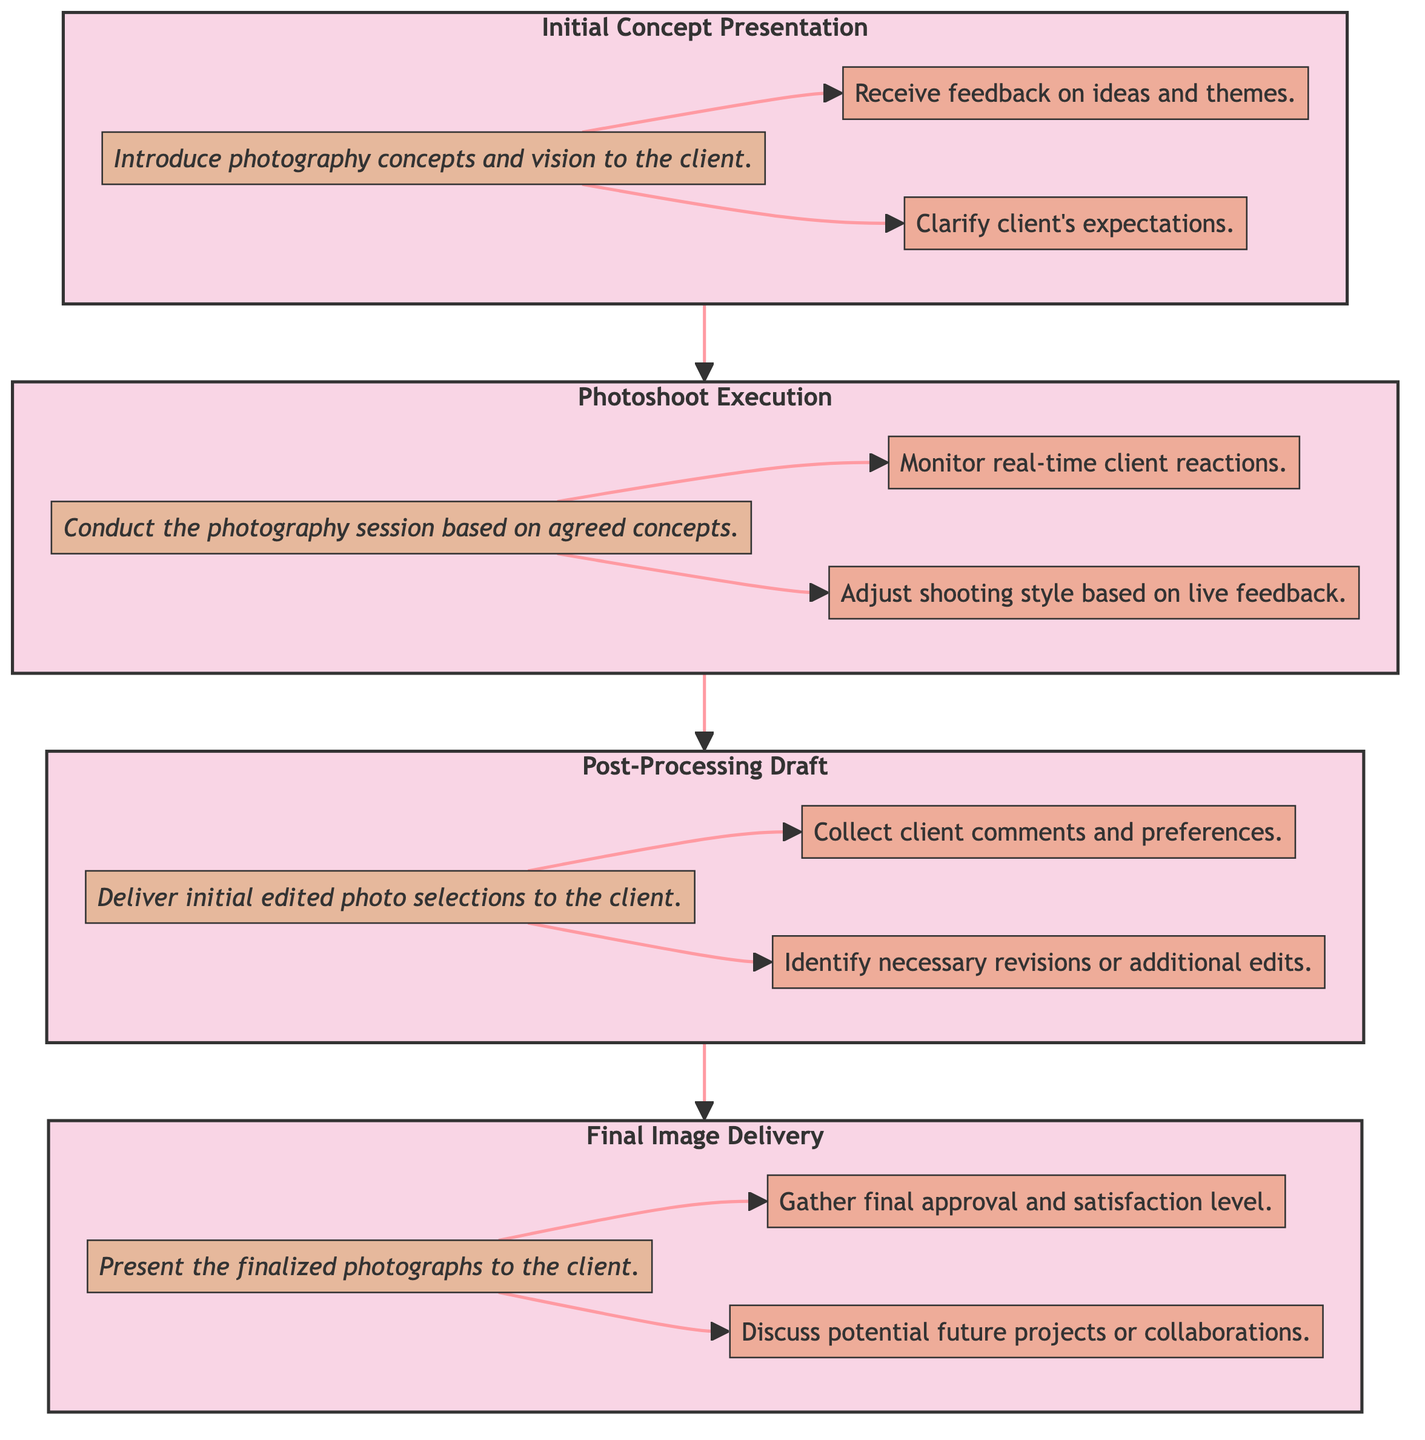What is the first stage in the client feedback loop? The diagram clearly indicates the order of stages, starting with "Initial Concept Presentation," which is the first stage in the client feedback loop.
Answer: Initial Concept Presentation How many response actions are linked to the "Final Image Delivery" stage? By examining the "Final Image Delivery" stage, we see two response actions associated with it: "Gather final approval and satisfaction level" and "Discuss potential future projects or collaborations." Thus, there are two response actions linked to this stage.
Answer: 2 What follows the "Photoshoot Execution" stage in the feedback loop? By tracing the flow of the diagram, "Photoshoot Execution" is followed by "Post-Processing Draft," indicating the progression in the feedback loop.
Answer: Post-Processing Draft Which stage involves receiving feedback on ideas and themes? The description for the "Initial Concept Presentation" stage specifies that one of the response actions is to "Receive feedback on ideas and themes," making it the stage where this occurs.
Answer: Initial Concept Presentation What is the primary activity during the "Photoshoot Execution" stage? Referring to the stage itself, the primary activity described is "Conduct the photography session based on agreed concepts," aligning with the objective of this stage.
Answer: Conduct the photography session based on agreed concepts How many total stages are present in the client feedback loop? The diagram lists four distinct stages: "Initial Concept Presentation," "Photoshoot Execution," "Post-Processing Draft," and "Final Image Delivery." Counting these stages gives a total of four.
Answer: 4 What do the arrows between the stages represent? The arrows in the diagram represent the flow of the client feedback loop, directing how one stage leads to the next in the overall process.
Answer: Flow of the client feedback loop What action is taken after delivering the initial edited photo selections? After delivering the initial edited photo selections in the "Post-Processing Draft," the actions include collecting client comments and identifying necessary revisions or additional edits, which denote the next steps taken in response to the delivery.
Answer: Collect client comments and preferences What type of feedback is monitored during the "Photoshoot Execution"? During the "Photoshoot Execution" stage, one of the key response actions is to "Monitor real-time client reactions," indicating the specific type of feedback being observed in this context.
Answer: Monitor real-time client reactions 